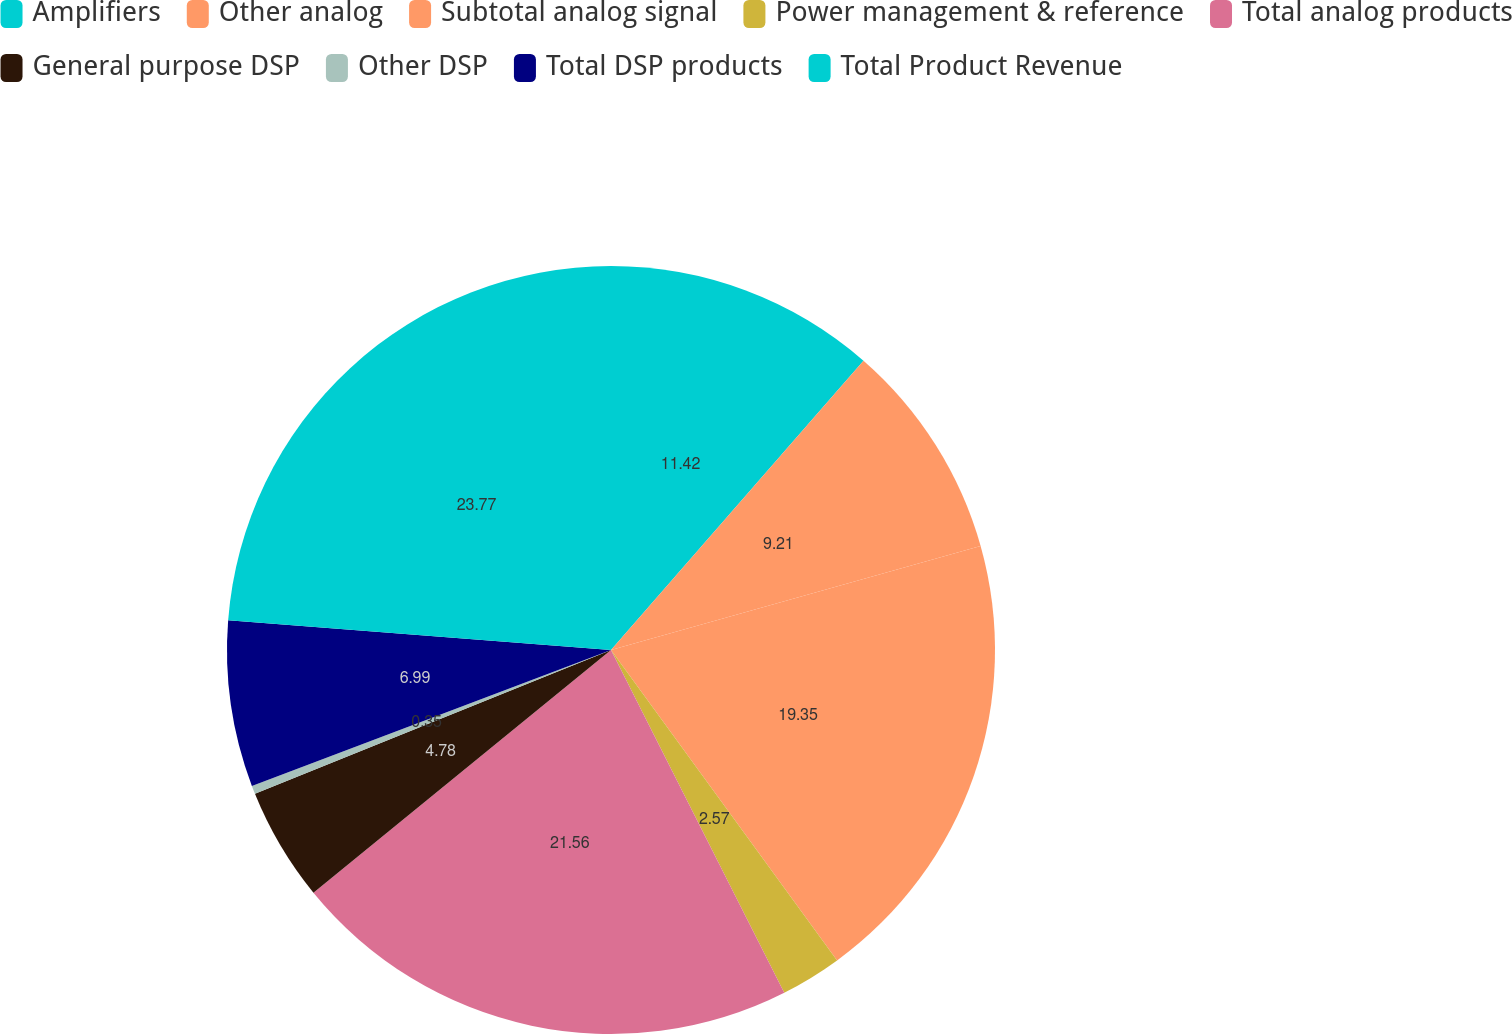Convert chart to OTSL. <chart><loc_0><loc_0><loc_500><loc_500><pie_chart><fcel>Amplifiers<fcel>Other analog<fcel>Subtotal analog signal<fcel>Power management & reference<fcel>Total analog products<fcel>General purpose DSP<fcel>Other DSP<fcel>Total DSP products<fcel>Total Product Revenue<nl><fcel>11.42%<fcel>9.21%<fcel>19.35%<fcel>2.57%<fcel>21.56%<fcel>4.78%<fcel>0.35%<fcel>6.99%<fcel>23.77%<nl></chart> 